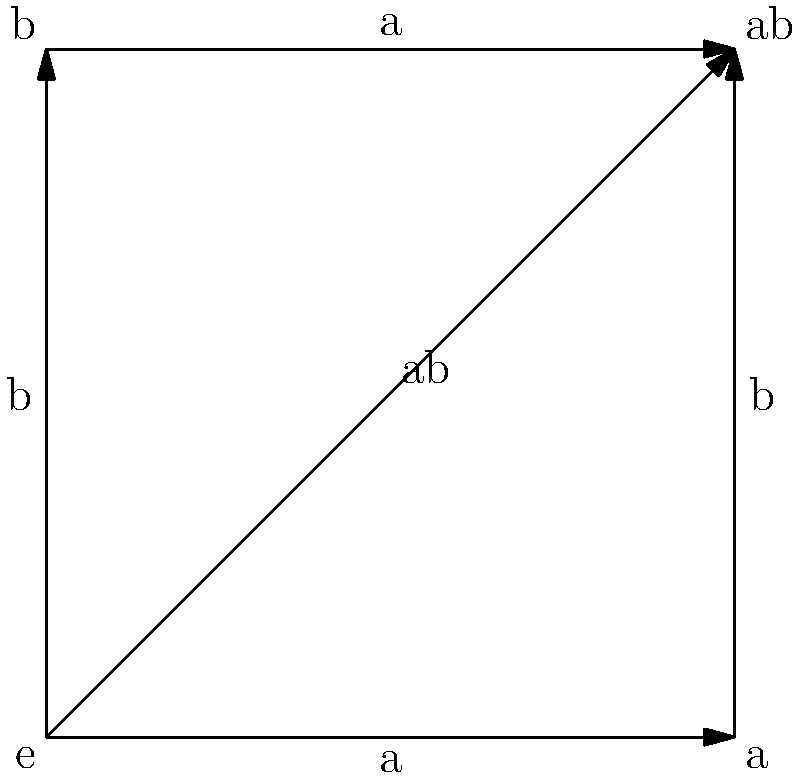In the Cayley graph of a group $G = \{e, a, b, ab\}$ shown above, identify the subgroup generated by the element $a$. How does this subgroup appear visually in the graph, and what does this representation tell us about the structure of $G$? To solve this problem, let's follow these steps:

1) First, recall that a subgroup generated by an element $a$ consists of all powers of $a$, including $e$ (the identity element) and $a^{-1}$.

2) In the given Cayley graph:
   - $e$ is the identity element
   - $a$ is represented by the horizontal edges
   - $b$ is represented by the vertical edges
   - $ab$ is represented by the diagonal edge

3) To find the subgroup generated by $a$, we start at $e$ and follow the edges labeled $a$:
   - Starting at $e$, following $a$ takes us to the vertex labeled $a$
   - From $a$, following $a$ again takes us back to $e$

4) This means that $a^2 = e$, or $a^{-1} = a$

5) Therefore, the subgroup generated by $a$ is $\{e, a\}$

6) Visually, this subgroup appears as the horizontal line in the Cayley graph, connecting $e$ and $a$

7) This visual representation tells us that:
   - The subgroup $\{e, a\}$ has order 2
   - $a$ is an element of order 2 (since $a^2 = e$)
   - $G$ has a cyclic subgroup of order 2

8) Moreover, we can see that $G$ is not cyclic, as no single element generates the entire group. It's actually isomorphic to the Klein four-group $V_4$ or $\mathbb{Z}_2 \times \mathbb{Z}_2$

This visualization helps us understand the structure of $G$ and its subgroups more intuitively than just looking at the group table.
Answer: The subgroup $\{e, a\}$ appears as a horizontal line, indicating $G \cong V_4$. 